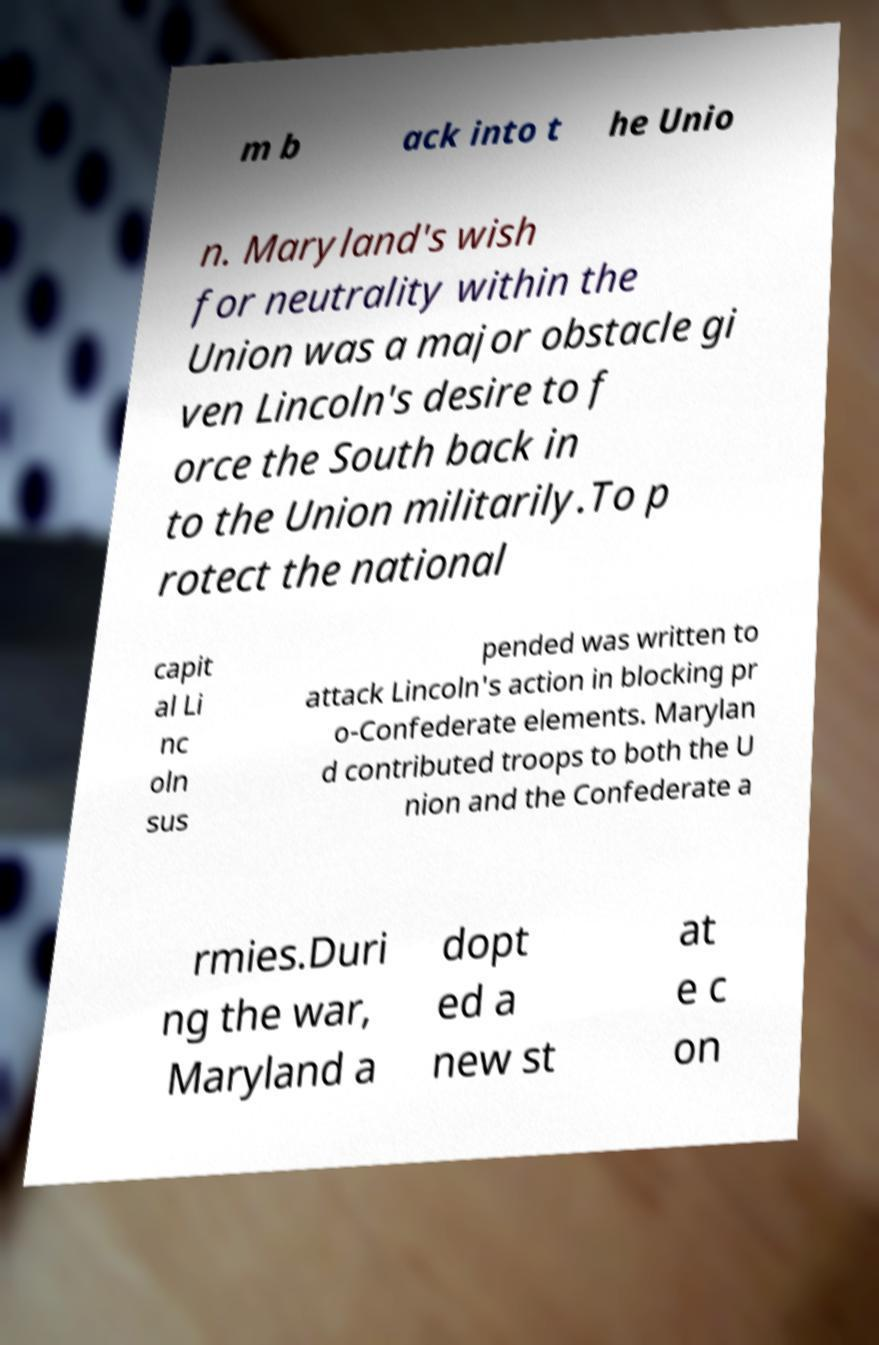I need the written content from this picture converted into text. Can you do that? m b ack into t he Unio n. Maryland's wish for neutrality within the Union was a major obstacle gi ven Lincoln's desire to f orce the South back in to the Union militarily.To p rotect the national capit al Li nc oln sus pended was written to attack Lincoln's action in blocking pr o-Confederate elements. Marylan d contributed troops to both the U nion and the Confederate a rmies.Duri ng the war, Maryland a dopt ed a new st at e c on 